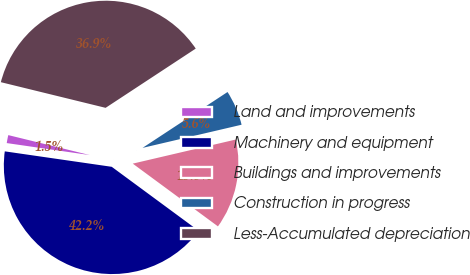Convert chart. <chart><loc_0><loc_0><loc_500><loc_500><pie_chart><fcel>Land and improvements<fcel>Machinery and equipment<fcel>Buildings and improvements<fcel>Construction in progress<fcel>Less-Accumulated depreciation<nl><fcel>1.54%<fcel>42.18%<fcel>13.76%<fcel>5.6%<fcel>36.92%<nl></chart> 